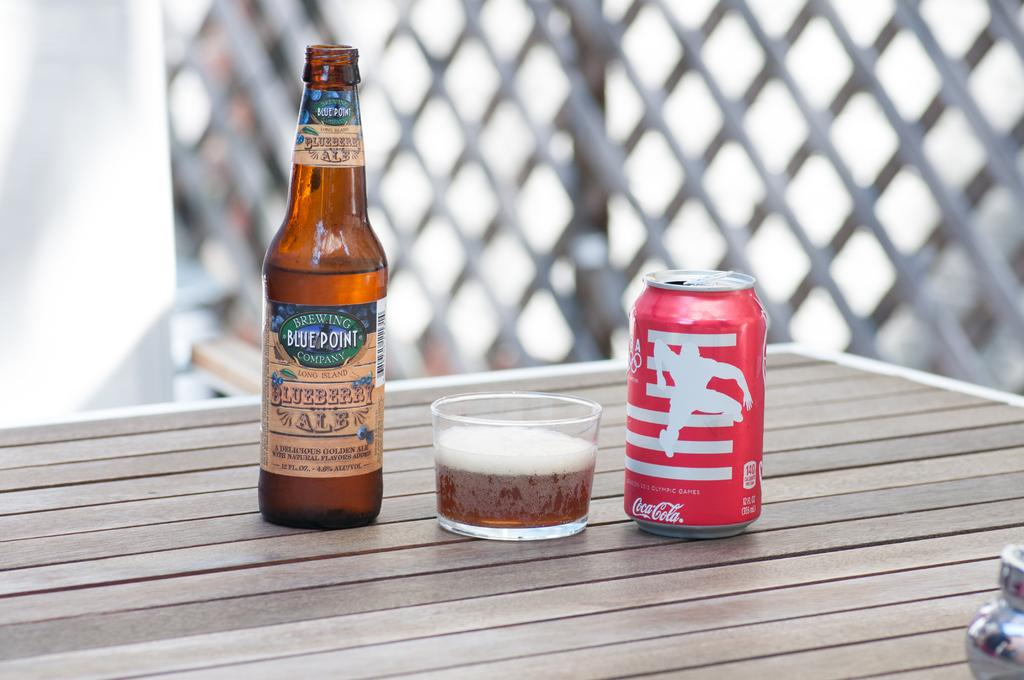<image>
Provide a brief description of the given image. a bottle of beer and a can of coke with non English lettering on it 